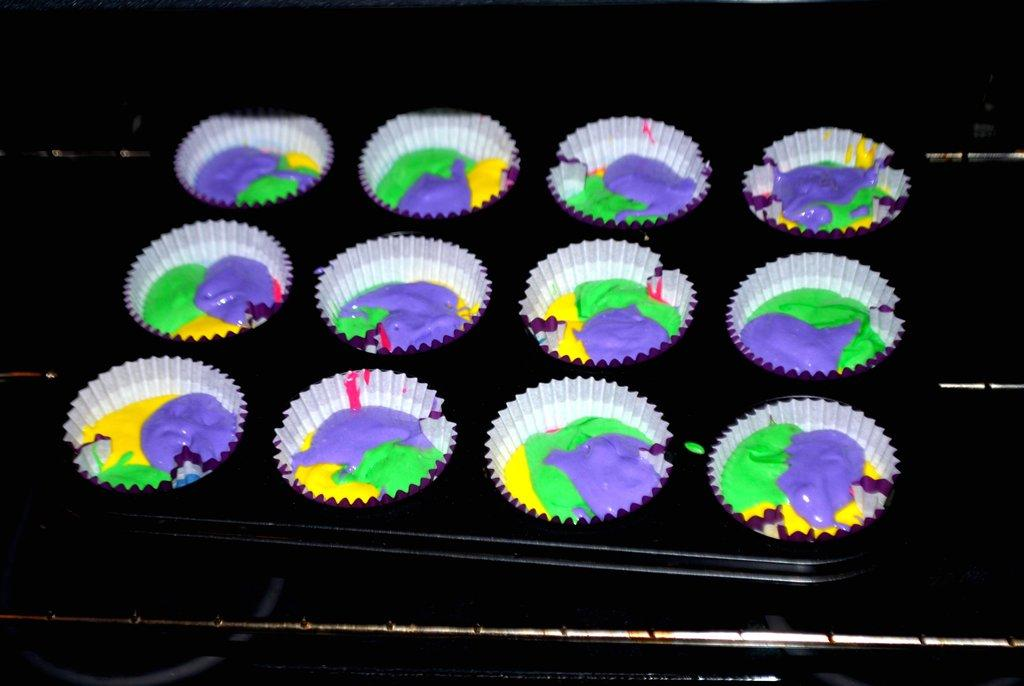What type of containers are present in the image? There are paint cups in the image. What can be seen at the bottom of the image? There is a rod at the bottom of the image. How many pigs are performing in the image? There are no pigs present in the image. What type of structure is the paint cup a part of in the image? The provided facts do not mention any structure associated with the paint cups. 